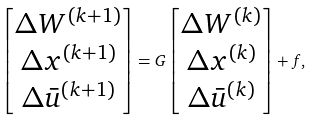<formula> <loc_0><loc_0><loc_500><loc_500>\begin{bmatrix} \Delta W ^ { ( k + 1 ) } \\ \Delta x ^ { ( k + 1 ) } \\ \Delta \bar { u } ^ { ( k + 1 ) } \end{bmatrix} = G \begin{bmatrix} \Delta W ^ { ( k ) } \\ \Delta x ^ { ( k ) } \\ \Delta \bar { u } ^ { ( k ) } \end{bmatrix} + f ,</formula> 